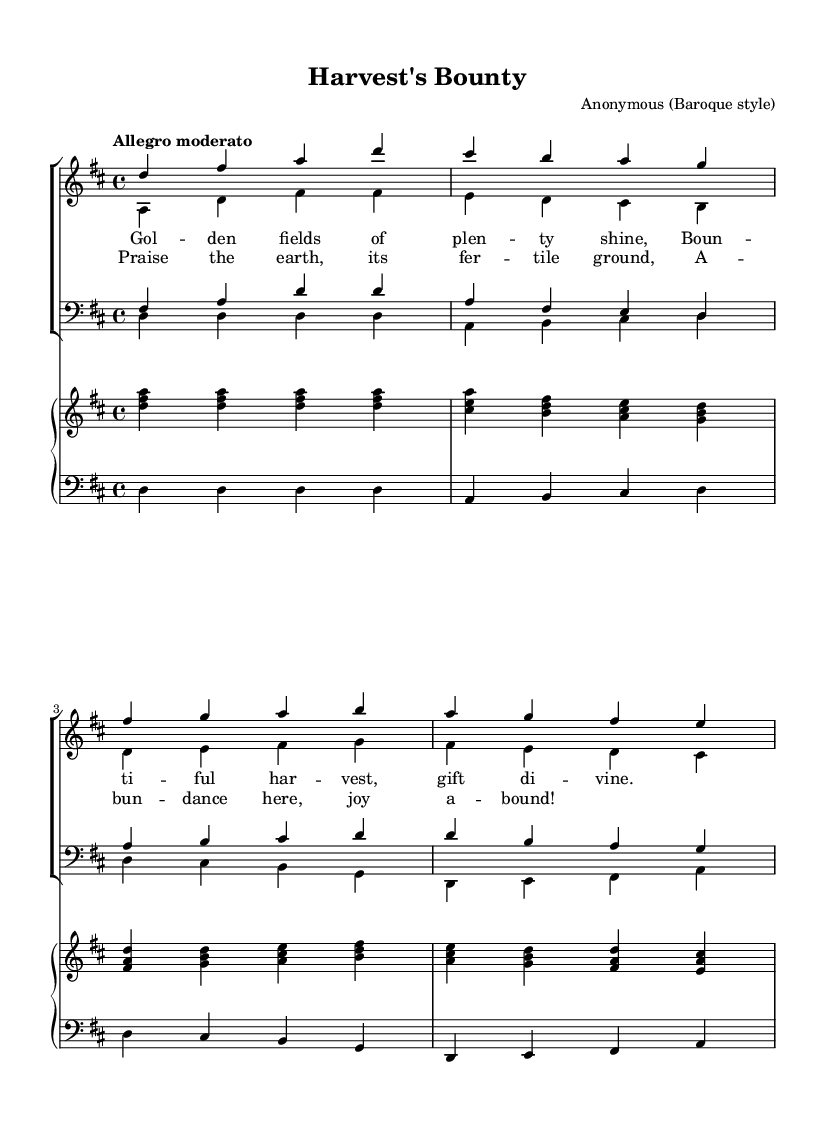What is the key signature of this music? The key signature is D major, which has two sharps: F# and C#. This can be determined by looking at the key signature indicated at the beginning of the staff.
Answer: D major What is the time signature of this music? The time signature is 4/4, indicating there are four beats in a measure and the quarter note receives one beat. This is found at the beginning of the score.
Answer: 4/4 What is the tempo marking of this music? The tempo marking is "Allegro moderato," which indicates a moderately fast pace. This is clearly stated above the staff in the score.
Answer: Allegro moderato How many staves are used for the choir? There are four staves used for the choir, two for women (soprano and alto) and two for men (tenor and bass). This can be counted by observing the separate staves for each vocal group in the score.
Answer: Four Which voice part has the highest notes? The soprano part has the highest notes, as it is written in the octave above the alto, tenor, and bass parts. This is evident when comparing the pitch ranges of each voice part in the score.
Answer: Soprano What is the overall theme represented in the lyrics? The overall theme represented in the lyrics is one of abundance and gratitude for a successful harvest, as suggested by phrases mentioning "fields of plenty" and "bounteous harvest." This can be inferred from the content of the lyrics indicated in the score.
Answer: Abundance How would you classify the texture of this choral work? The texture of this choral work is predominantly homophonic, where all parts harmonize together, often moving in similar rhythms. This is identifiable by observing how the voices sing in conjunction, supporting a single melodic line.
Answer: Homophonic 